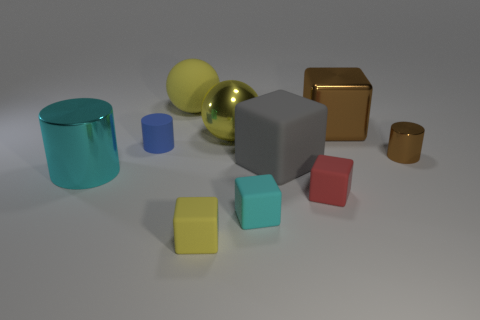How many things are either tiny red matte things that are on the right side of the cyan rubber object or blocks in front of the blue rubber cylinder?
Provide a short and direct response. 4. Do the metal object in front of the gray rubber block and the large gray rubber thing have the same size?
Provide a short and direct response. Yes. There is a brown shiny object that is the same shape as the tiny blue rubber object; what size is it?
Give a very brief answer. Small. There is a brown object that is the same size as the yellow matte cube; what material is it?
Offer a very short reply. Metal. There is a big brown thing that is the same shape as the tiny yellow rubber thing; what is it made of?
Make the answer very short. Metal. What number of other things are the same size as the cyan shiny cylinder?
Your response must be concise. 4. There is a block that is the same color as the big shiny ball; what is its size?
Offer a very short reply. Small. What number of objects are the same color as the large shiny cube?
Keep it short and to the point. 1. The small blue rubber thing has what shape?
Give a very brief answer. Cylinder. There is a tiny thing that is behind the gray cube and to the right of the gray matte block; what color is it?
Your response must be concise. Brown. 